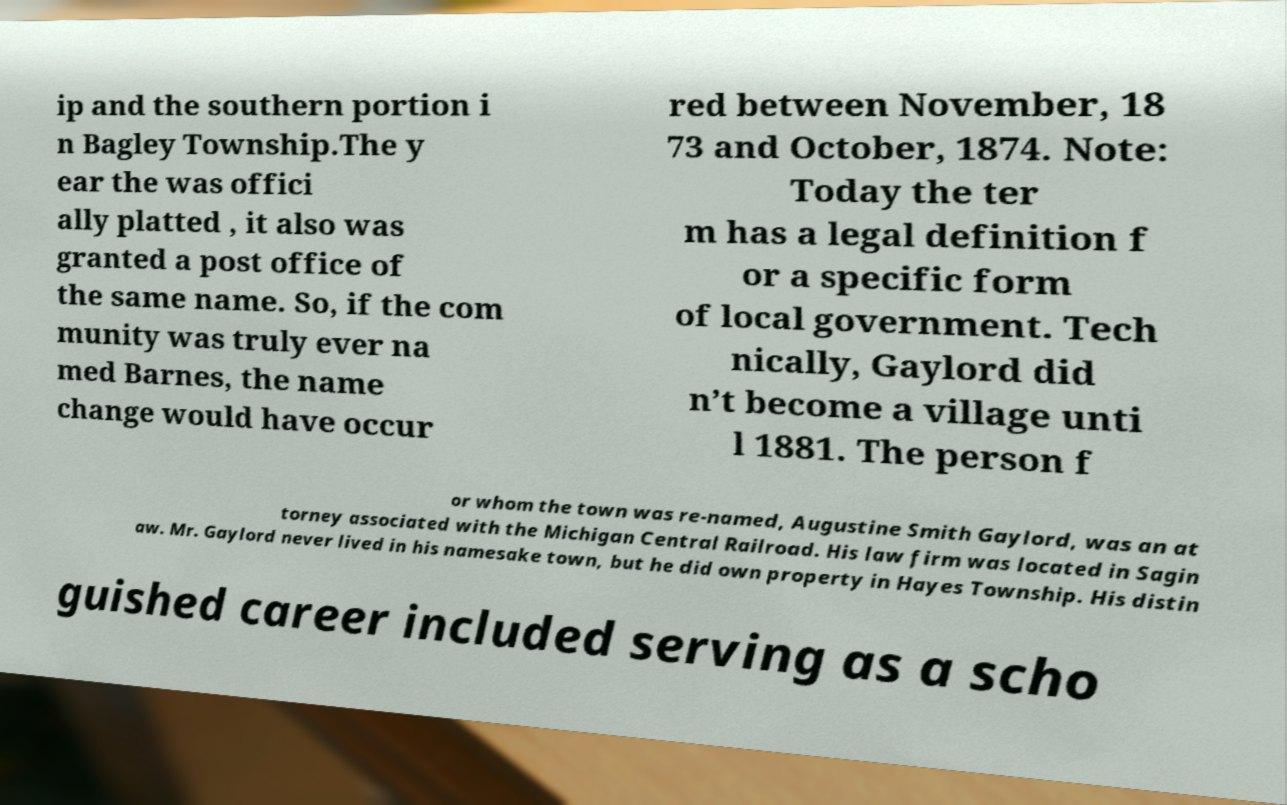Could you extract and type out the text from this image? ip and the southern portion i n Bagley Township.The y ear the was offici ally platted , it also was granted a post office of the same name. So, if the com munity was truly ever na med Barnes, the name change would have occur red between November, 18 73 and October, 1874. Note: Today the ter m has a legal definition f or a specific form of local government. Tech nically, Gaylord did n’t become a village unti l 1881. The person f or whom the town was re-named, Augustine Smith Gaylord, was an at torney associated with the Michigan Central Railroad. His law firm was located in Sagin aw. Mr. Gaylord never lived in his namesake town, but he did own property in Hayes Township. His distin guished career included serving as a scho 